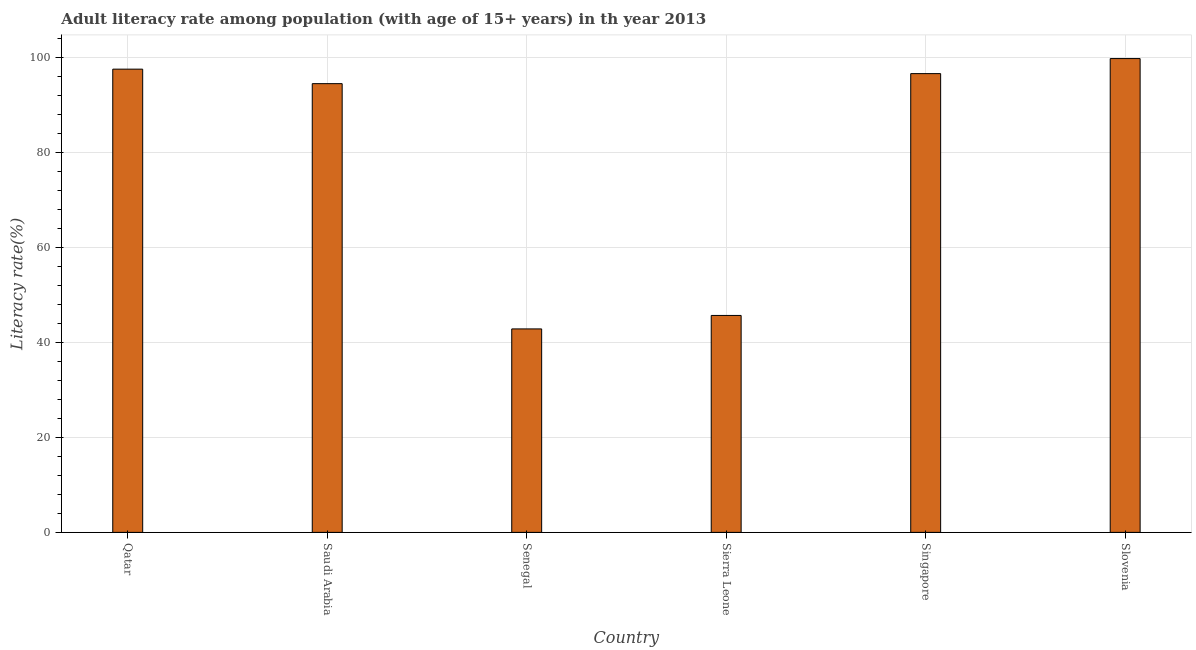Does the graph contain any zero values?
Your answer should be compact. No. Does the graph contain grids?
Make the answer very short. Yes. What is the title of the graph?
Keep it short and to the point. Adult literacy rate among population (with age of 15+ years) in th year 2013. What is the label or title of the X-axis?
Your answer should be very brief. Country. What is the label or title of the Y-axis?
Offer a terse response. Literacy rate(%). What is the adult literacy rate in Senegal?
Offer a very short reply. 42.82. Across all countries, what is the maximum adult literacy rate?
Your answer should be compact. 99.71. Across all countries, what is the minimum adult literacy rate?
Your response must be concise. 42.82. In which country was the adult literacy rate maximum?
Keep it short and to the point. Slovenia. In which country was the adult literacy rate minimum?
Your answer should be very brief. Senegal. What is the sum of the adult literacy rate?
Ensure brevity in your answer.  476.62. What is the difference between the adult literacy rate in Saudi Arabia and Singapore?
Offer a terse response. -2.11. What is the average adult literacy rate per country?
Offer a terse response. 79.44. What is the median adult literacy rate?
Your answer should be compact. 95.48. In how many countries, is the adult literacy rate greater than 20 %?
Offer a very short reply. 6. What is the ratio of the adult literacy rate in Qatar to that in Saudi Arabia?
Provide a succinct answer. 1.03. Is the difference between the adult literacy rate in Qatar and Singapore greater than the difference between any two countries?
Offer a very short reply. No. What is the difference between the highest and the second highest adult literacy rate?
Ensure brevity in your answer.  2.23. What is the difference between the highest and the lowest adult literacy rate?
Your response must be concise. 56.89. In how many countries, is the adult literacy rate greater than the average adult literacy rate taken over all countries?
Provide a succinct answer. 4. Are all the bars in the graph horizontal?
Offer a very short reply. No. What is the difference between two consecutive major ticks on the Y-axis?
Offer a very short reply. 20. Are the values on the major ticks of Y-axis written in scientific E-notation?
Offer a terse response. No. What is the Literacy rate(%) of Qatar?
Make the answer very short. 97.48. What is the Literacy rate(%) of Saudi Arabia?
Your response must be concise. 94.43. What is the Literacy rate(%) in Senegal?
Provide a short and direct response. 42.82. What is the Literacy rate(%) of Sierra Leone?
Make the answer very short. 45.65. What is the Literacy rate(%) of Singapore?
Offer a very short reply. 96.54. What is the Literacy rate(%) in Slovenia?
Your answer should be compact. 99.71. What is the difference between the Literacy rate(%) in Qatar and Saudi Arabia?
Your response must be concise. 3.05. What is the difference between the Literacy rate(%) in Qatar and Senegal?
Your answer should be compact. 54.66. What is the difference between the Literacy rate(%) in Qatar and Sierra Leone?
Make the answer very short. 51.83. What is the difference between the Literacy rate(%) in Qatar and Singapore?
Your answer should be compact. 0.94. What is the difference between the Literacy rate(%) in Qatar and Slovenia?
Your answer should be compact. -2.23. What is the difference between the Literacy rate(%) in Saudi Arabia and Senegal?
Offer a very short reply. 51.61. What is the difference between the Literacy rate(%) in Saudi Arabia and Sierra Leone?
Offer a very short reply. 48.78. What is the difference between the Literacy rate(%) in Saudi Arabia and Singapore?
Offer a terse response. -2.11. What is the difference between the Literacy rate(%) in Saudi Arabia and Slovenia?
Offer a terse response. -5.28. What is the difference between the Literacy rate(%) in Senegal and Sierra Leone?
Your response must be concise. -2.83. What is the difference between the Literacy rate(%) in Senegal and Singapore?
Offer a terse response. -53.72. What is the difference between the Literacy rate(%) in Senegal and Slovenia?
Offer a terse response. -56.89. What is the difference between the Literacy rate(%) in Sierra Leone and Singapore?
Ensure brevity in your answer.  -50.89. What is the difference between the Literacy rate(%) in Sierra Leone and Slovenia?
Your answer should be compact. -54.06. What is the difference between the Literacy rate(%) in Singapore and Slovenia?
Offer a very short reply. -3.17. What is the ratio of the Literacy rate(%) in Qatar to that in Saudi Arabia?
Your answer should be compact. 1.03. What is the ratio of the Literacy rate(%) in Qatar to that in Senegal?
Offer a very short reply. 2.28. What is the ratio of the Literacy rate(%) in Qatar to that in Sierra Leone?
Offer a very short reply. 2.13. What is the ratio of the Literacy rate(%) in Qatar to that in Slovenia?
Make the answer very short. 0.98. What is the ratio of the Literacy rate(%) in Saudi Arabia to that in Senegal?
Provide a succinct answer. 2.21. What is the ratio of the Literacy rate(%) in Saudi Arabia to that in Sierra Leone?
Offer a very short reply. 2.07. What is the ratio of the Literacy rate(%) in Saudi Arabia to that in Singapore?
Your response must be concise. 0.98. What is the ratio of the Literacy rate(%) in Saudi Arabia to that in Slovenia?
Provide a short and direct response. 0.95. What is the ratio of the Literacy rate(%) in Senegal to that in Sierra Leone?
Your answer should be compact. 0.94. What is the ratio of the Literacy rate(%) in Senegal to that in Singapore?
Your answer should be very brief. 0.44. What is the ratio of the Literacy rate(%) in Senegal to that in Slovenia?
Give a very brief answer. 0.43. What is the ratio of the Literacy rate(%) in Sierra Leone to that in Singapore?
Make the answer very short. 0.47. What is the ratio of the Literacy rate(%) in Sierra Leone to that in Slovenia?
Offer a very short reply. 0.46. 